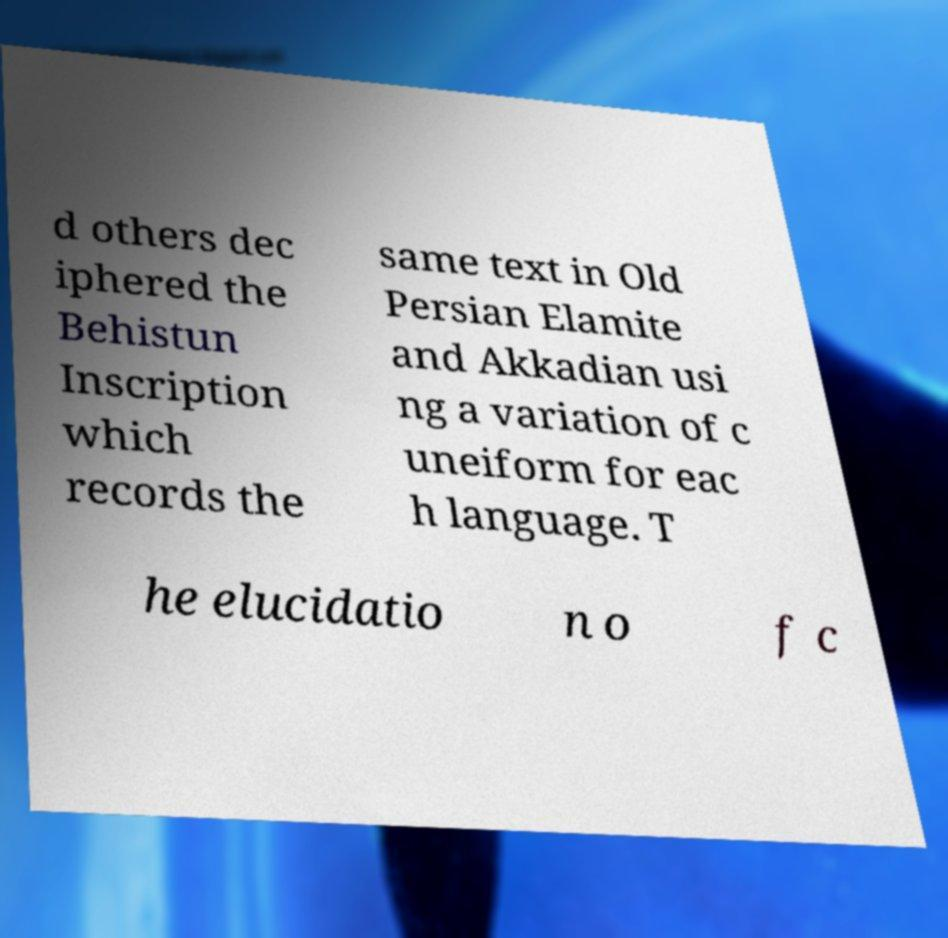There's text embedded in this image that I need extracted. Can you transcribe it verbatim? d others dec iphered the Behistun Inscription which records the same text in Old Persian Elamite and Akkadian usi ng a variation of c uneiform for eac h language. T he elucidatio n o f c 